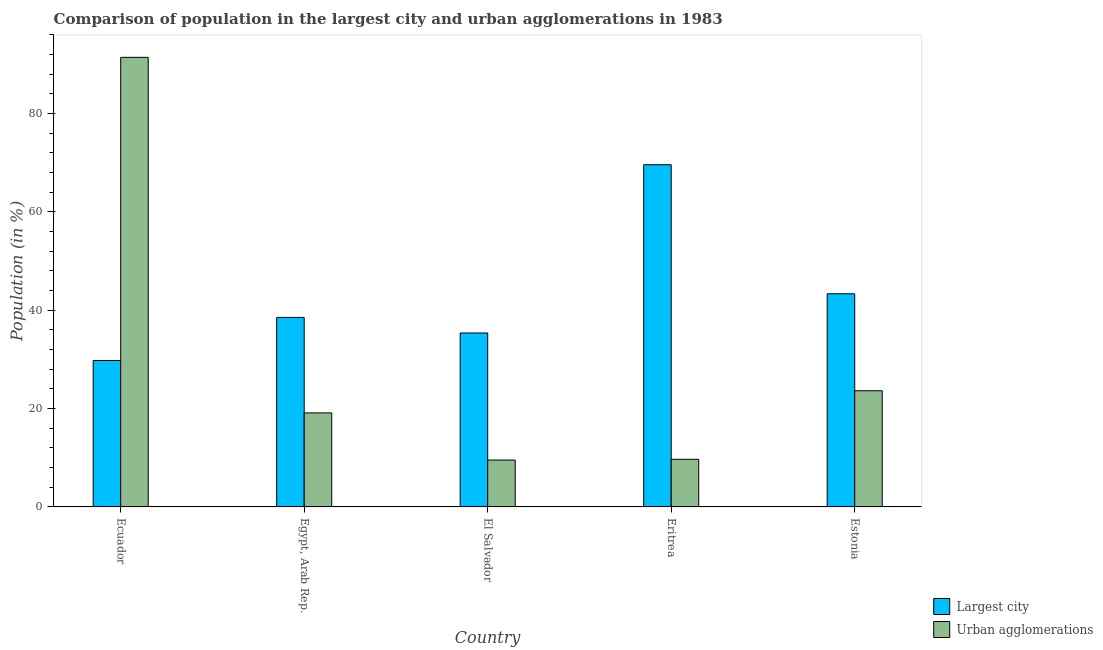How many groups of bars are there?
Offer a very short reply. 5. Are the number of bars per tick equal to the number of legend labels?
Keep it short and to the point. Yes. How many bars are there on the 2nd tick from the right?
Make the answer very short. 2. What is the label of the 5th group of bars from the left?
Offer a terse response. Estonia. In how many cases, is the number of bars for a given country not equal to the number of legend labels?
Ensure brevity in your answer.  0. What is the population in the largest city in Estonia?
Offer a very short reply. 43.35. Across all countries, what is the maximum population in urban agglomerations?
Ensure brevity in your answer.  91.44. Across all countries, what is the minimum population in urban agglomerations?
Provide a succinct answer. 9.53. In which country was the population in the largest city maximum?
Provide a succinct answer. Eritrea. In which country was the population in urban agglomerations minimum?
Keep it short and to the point. El Salvador. What is the total population in urban agglomerations in the graph?
Ensure brevity in your answer.  153.42. What is the difference between the population in the largest city in Ecuador and that in Egypt, Arab Rep.?
Make the answer very short. -8.76. What is the difference between the population in urban agglomerations in Egypt, Arab Rep. and the population in the largest city in Eritrea?
Ensure brevity in your answer.  -50.48. What is the average population in the largest city per country?
Provide a succinct answer. 43.33. What is the difference between the population in the largest city and population in urban agglomerations in Estonia?
Give a very brief answer. 19.72. What is the ratio of the population in the largest city in Egypt, Arab Rep. to that in Eritrea?
Keep it short and to the point. 0.55. Is the difference between the population in urban agglomerations in Egypt, Arab Rep. and El Salvador greater than the difference between the population in the largest city in Egypt, Arab Rep. and El Salvador?
Keep it short and to the point. Yes. What is the difference between the highest and the second highest population in the largest city?
Provide a succinct answer. 26.25. What is the difference between the highest and the lowest population in urban agglomerations?
Your answer should be very brief. 81.91. Is the sum of the population in urban agglomerations in Eritrea and Estonia greater than the maximum population in the largest city across all countries?
Give a very brief answer. No. What does the 1st bar from the left in El Salvador represents?
Offer a very short reply. Largest city. What does the 1st bar from the right in Egypt, Arab Rep. represents?
Your answer should be compact. Urban agglomerations. How many bars are there?
Give a very brief answer. 10. How many countries are there in the graph?
Your response must be concise. 5. What is the difference between two consecutive major ticks on the Y-axis?
Ensure brevity in your answer.  20. How are the legend labels stacked?
Offer a very short reply. Vertical. What is the title of the graph?
Your answer should be compact. Comparison of population in the largest city and urban agglomerations in 1983. What is the Population (in %) of Largest city in Ecuador?
Give a very brief answer. 29.78. What is the Population (in %) of Urban agglomerations in Ecuador?
Your response must be concise. 91.44. What is the Population (in %) in Largest city in Egypt, Arab Rep.?
Offer a terse response. 38.55. What is the Population (in %) in Urban agglomerations in Egypt, Arab Rep.?
Offer a very short reply. 19.12. What is the Population (in %) in Largest city in El Salvador?
Provide a short and direct response. 35.38. What is the Population (in %) in Urban agglomerations in El Salvador?
Provide a succinct answer. 9.53. What is the Population (in %) in Largest city in Eritrea?
Provide a succinct answer. 69.6. What is the Population (in %) in Urban agglomerations in Eritrea?
Make the answer very short. 9.69. What is the Population (in %) of Largest city in Estonia?
Offer a very short reply. 43.35. What is the Population (in %) of Urban agglomerations in Estonia?
Your answer should be compact. 23.63. Across all countries, what is the maximum Population (in %) in Largest city?
Provide a short and direct response. 69.6. Across all countries, what is the maximum Population (in %) in Urban agglomerations?
Ensure brevity in your answer.  91.44. Across all countries, what is the minimum Population (in %) in Largest city?
Ensure brevity in your answer.  29.78. Across all countries, what is the minimum Population (in %) of Urban agglomerations?
Your answer should be compact. 9.53. What is the total Population (in %) in Largest city in the graph?
Keep it short and to the point. 216.66. What is the total Population (in %) of Urban agglomerations in the graph?
Offer a very short reply. 153.42. What is the difference between the Population (in %) of Largest city in Ecuador and that in Egypt, Arab Rep.?
Give a very brief answer. -8.76. What is the difference between the Population (in %) in Urban agglomerations in Ecuador and that in Egypt, Arab Rep.?
Your response must be concise. 72.32. What is the difference between the Population (in %) in Largest city in Ecuador and that in El Salvador?
Offer a very short reply. -5.6. What is the difference between the Population (in %) in Urban agglomerations in Ecuador and that in El Salvador?
Give a very brief answer. 81.91. What is the difference between the Population (in %) of Largest city in Ecuador and that in Eritrea?
Keep it short and to the point. -39.82. What is the difference between the Population (in %) in Urban agglomerations in Ecuador and that in Eritrea?
Provide a succinct answer. 81.76. What is the difference between the Population (in %) in Largest city in Ecuador and that in Estonia?
Your answer should be very brief. -13.57. What is the difference between the Population (in %) in Urban agglomerations in Ecuador and that in Estonia?
Your answer should be very brief. 67.81. What is the difference between the Population (in %) in Largest city in Egypt, Arab Rep. and that in El Salvador?
Ensure brevity in your answer.  3.17. What is the difference between the Population (in %) in Urban agglomerations in Egypt, Arab Rep. and that in El Salvador?
Offer a terse response. 9.59. What is the difference between the Population (in %) of Largest city in Egypt, Arab Rep. and that in Eritrea?
Ensure brevity in your answer.  -31.05. What is the difference between the Population (in %) of Urban agglomerations in Egypt, Arab Rep. and that in Eritrea?
Offer a terse response. 9.43. What is the difference between the Population (in %) in Largest city in Egypt, Arab Rep. and that in Estonia?
Provide a succinct answer. -4.81. What is the difference between the Population (in %) in Urban agglomerations in Egypt, Arab Rep. and that in Estonia?
Your answer should be very brief. -4.51. What is the difference between the Population (in %) in Largest city in El Salvador and that in Eritrea?
Provide a short and direct response. -34.22. What is the difference between the Population (in %) in Urban agglomerations in El Salvador and that in Eritrea?
Provide a succinct answer. -0.16. What is the difference between the Population (in %) of Largest city in El Salvador and that in Estonia?
Your answer should be compact. -7.97. What is the difference between the Population (in %) of Urban agglomerations in El Salvador and that in Estonia?
Your answer should be very brief. -14.1. What is the difference between the Population (in %) in Largest city in Eritrea and that in Estonia?
Provide a short and direct response. 26.25. What is the difference between the Population (in %) of Urban agglomerations in Eritrea and that in Estonia?
Ensure brevity in your answer.  -13.94. What is the difference between the Population (in %) of Largest city in Ecuador and the Population (in %) of Urban agglomerations in Egypt, Arab Rep.?
Offer a terse response. 10.66. What is the difference between the Population (in %) of Largest city in Ecuador and the Population (in %) of Urban agglomerations in El Salvador?
Keep it short and to the point. 20.25. What is the difference between the Population (in %) in Largest city in Ecuador and the Population (in %) in Urban agglomerations in Eritrea?
Keep it short and to the point. 20.09. What is the difference between the Population (in %) in Largest city in Ecuador and the Population (in %) in Urban agglomerations in Estonia?
Give a very brief answer. 6.15. What is the difference between the Population (in %) in Largest city in Egypt, Arab Rep. and the Population (in %) in Urban agglomerations in El Salvador?
Your answer should be compact. 29.01. What is the difference between the Population (in %) in Largest city in Egypt, Arab Rep. and the Population (in %) in Urban agglomerations in Eritrea?
Offer a terse response. 28.86. What is the difference between the Population (in %) of Largest city in Egypt, Arab Rep. and the Population (in %) of Urban agglomerations in Estonia?
Keep it short and to the point. 14.91. What is the difference between the Population (in %) in Largest city in El Salvador and the Population (in %) in Urban agglomerations in Eritrea?
Your answer should be very brief. 25.69. What is the difference between the Population (in %) in Largest city in El Salvador and the Population (in %) in Urban agglomerations in Estonia?
Provide a short and direct response. 11.75. What is the difference between the Population (in %) of Largest city in Eritrea and the Population (in %) of Urban agglomerations in Estonia?
Your answer should be very brief. 45.97. What is the average Population (in %) in Largest city per country?
Your answer should be very brief. 43.33. What is the average Population (in %) in Urban agglomerations per country?
Provide a succinct answer. 30.68. What is the difference between the Population (in %) in Largest city and Population (in %) in Urban agglomerations in Ecuador?
Your response must be concise. -61.66. What is the difference between the Population (in %) in Largest city and Population (in %) in Urban agglomerations in Egypt, Arab Rep.?
Offer a very short reply. 19.42. What is the difference between the Population (in %) in Largest city and Population (in %) in Urban agglomerations in El Salvador?
Provide a short and direct response. 25.85. What is the difference between the Population (in %) in Largest city and Population (in %) in Urban agglomerations in Eritrea?
Your response must be concise. 59.91. What is the difference between the Population (in %) of Largest city and Population (in %) of Urban agglomerations in Estonia?
Offer a very short reply. 19.72. What is the ratio of the Population (in %) of Largest city in Ecuador to that in Egypt, Arab Rep.?
Offer a terse response. 0.77. What is the ratio of the Population (in %) of Urban agglomerations in Ecuador to that in Egypt, Arab Rep.?
Your answer should be very brief. 4.78. What is the ratio of the Population (in %) in Largest city in Ecuador to that in El Salvador?
Offer a terse response. 0.84. What is the ratio of the Population (in %) in Urban agglomerations in Ecuador to that in El Salvador?
Provide a short and direct response. 9.59. What is the ratio of the Population (in %) in Largest city in Ecuador to that in Eritrea?
Provide a short and direct response. 0.43. What is the ratio of the Population (in %) in Urban agglomerations in Ecuador to that in Eritrea?
Ensure brevity in your answer.  9.44. What is the ratio of the Population (in %) of Largest city in Ecuador to that in Estonia?
Provide a short and direct response. 0.69. What is the ratio of the Population (in %) of Urban agglomerations in Ecuador to that in Estonia?
Ensure brevity in your answer.  3.87. What is the ratio of the Population (in %) of Largest city in Egypt, Arab Rep. to that in El Salvador?
Your answer should be compact. 1.09. What is the ratio of the Population (in %) of Urban agglomerations in Egypt, Arab Rep. to that in El Salvador?
Offer a terse response. 2.01. What is the ratio of the Population (in %) of Largest city in Egypt, Arab Rep. to that in Eritrea?
Provide a succinct answer. 0.55. What is the ratio of the Population (in %) in Urban agglomerations in Egypt, Arab Rep. to that in Eritrea?
Provide a short and direct response. 1.97. What is the ratio of the Population (in %) of Largest city in Egypt, Arab Rep. to that in Estonia?
Provide a succinct answer. 0.89. What is the ratio of the Population (in %) of Urban agglomerations in Egypt, Arab Rep. to that in Estonia?
Offer a very short reply. 0.81. What is the ratio of the Population (in %) in Largest city in El Salvador to that in Eritrea?
Offer a terse response. 0.51. What is the ratio of the Population (in %) in Urban agglomerations in El Salvador to that in Eritrea?
Your response must be concise. 0.98. What is the ratio of the Population (in %) in Largest city in El Salvador to that in Estonia?
Keep it short and to the point. 0.82. What is the ratio of the Population (in %) in Urban agglomerations in El Salvador to that in Estonia?
Give a very brief answer. 0.4. What is the ratio of the Population (in %) of Largest city in Eritrea to that in Estonia?
Offer a very short reply. 1.61. What is the ratio of the Population (in %) in Urban agglomerations in Eritrea to that in Estonia?
Give a very brief answer. 0.41. What is the difference between the highest and the second highest Population (in %) in Largest city?
Keep it short and to the point. 26.25. What is the difference between the highest and the second highest Population (in %) in Urban agglomerations?
Your answer should be compact. 67.81. What is the difference between the highest and the lowest Population (in %) of Largest city?
Provide a succinct answer. 39.82. What is the difference between the highest and the lowest Population (in %) in Urban agglomerations?
Your answer should be compact. 81.91. 